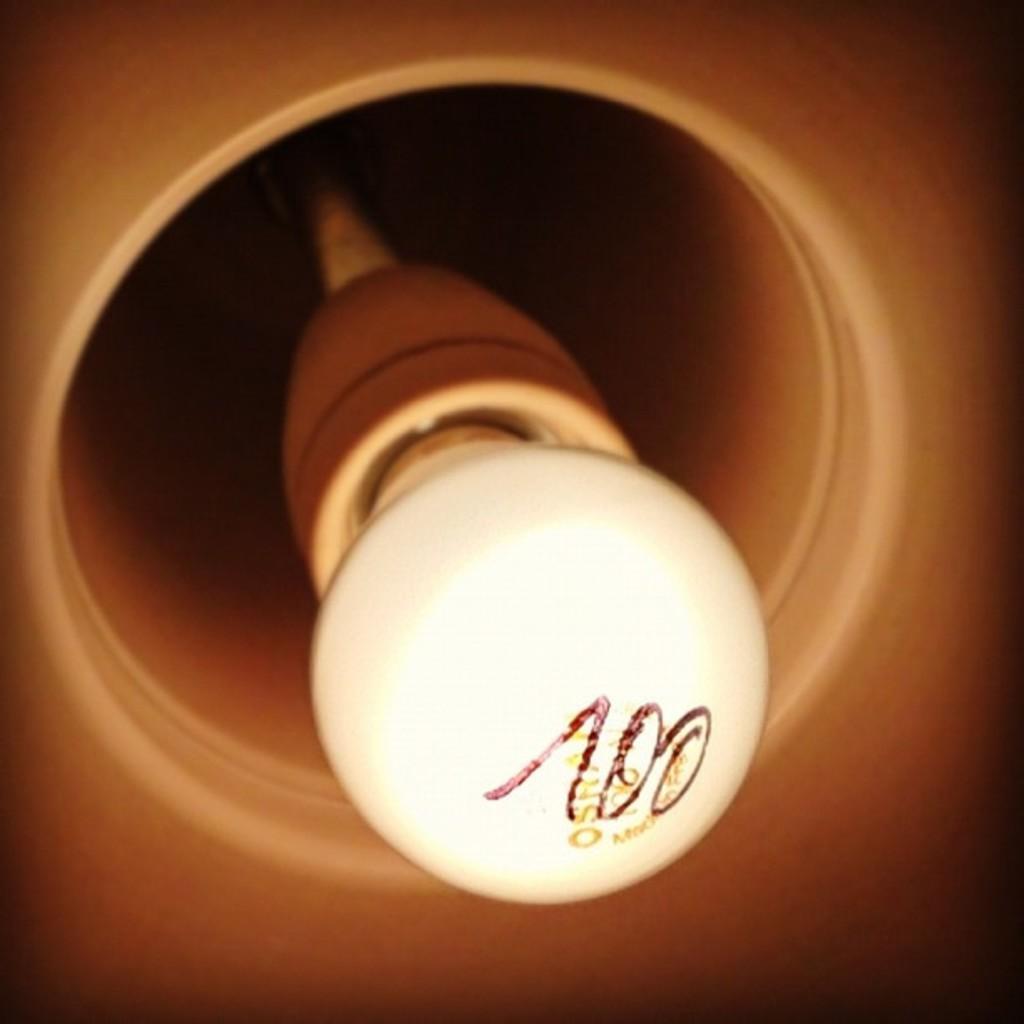Could you give a brief overview of what you see in this image? In this image we can see a blown bulb.  